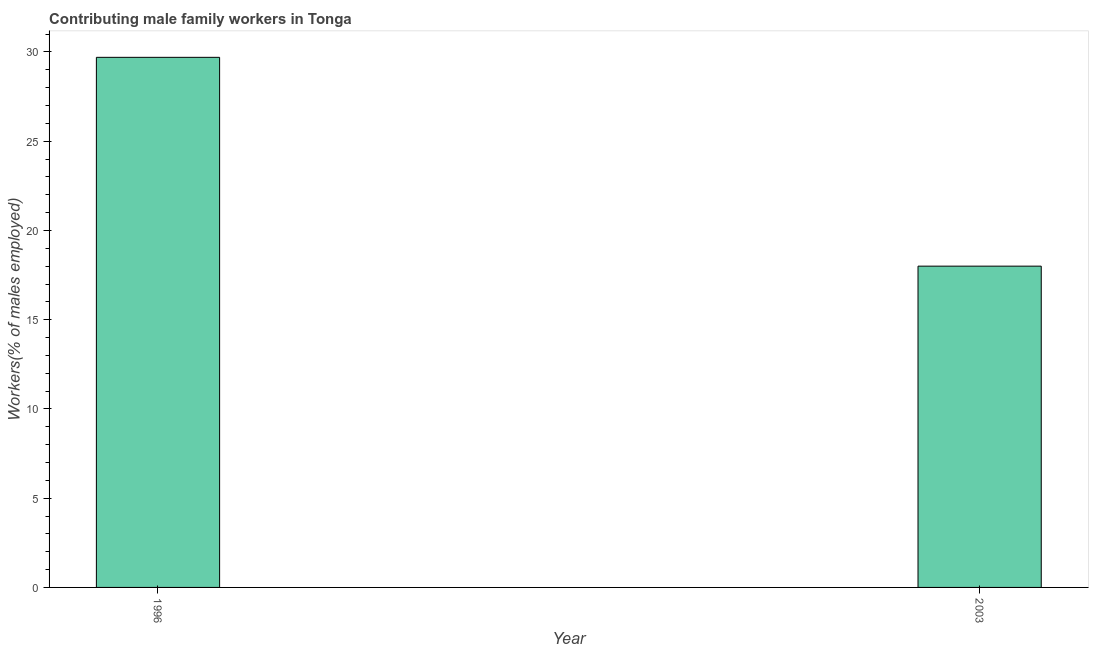Does the graph contain grids?
Ensure brevity in your answer.  No. What is the title of the graph?
Provide a succinct answer. Contributing male family workers in Tonga. What is the label or title of the X-axis?
Your response must be concise. Year. What is the label or title of the Y-axis?
Offer a very short reply. Workers(% of males employed). What is the contributing male family workers in 1996?
Provide a short and direct response. 29.7. Across all years, what is the maximum contributing male family workers?
Offer a very short reply. 29.7. Across all years, what is the minimum contributing male family workers?
Give a very brief answer. 18. What is the sum of the contributing male family workers?
Your response must be concise. 47.7. What is the difference between the contributing male family workers in 1996 and 2003?
Give a very brief answer. 11.7. What is the average contributing male family workers per year?
Provide a short and direct response. 23.85. What is the median contributing male family workers?
Provide a short and direct response. 23.85. What is the ratio of the contributing male family workers in 1996 to that in 2003?
Provide a succinct answer. 1.65. How many bars are there?
Your answer should be compact. 2. Are all the bars in the graph horizontal?
Your answer should be compact. No. What is the Workers(% of males employed) in 1996?
Offer a very short reply. 29.7. What is the ratio of the Workers(% of males employed) in 1996 to that in 2003?
Make the answer very short. 1.65. 